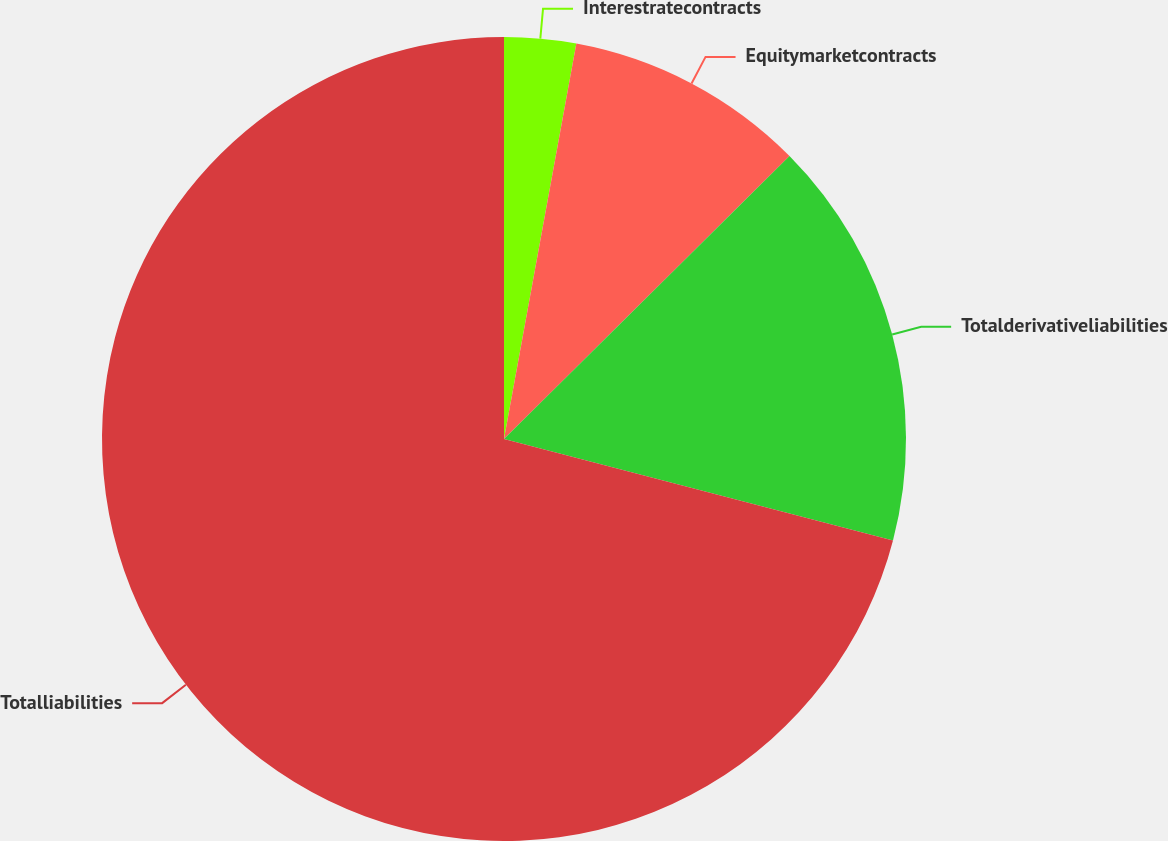Convert chart. <chart><loc_0><loc_0><loc_500><loc_500><pie_chart><fcel>Interestratecontracts<fcel>Equitymarketcontracts<fcel>Totalderivativeliabilities<fcel>Totalliabilities<nl><fcel>2.88%<fcel>9.69%<fcel>16.49%<fcel>70.94%<nl></chart> 